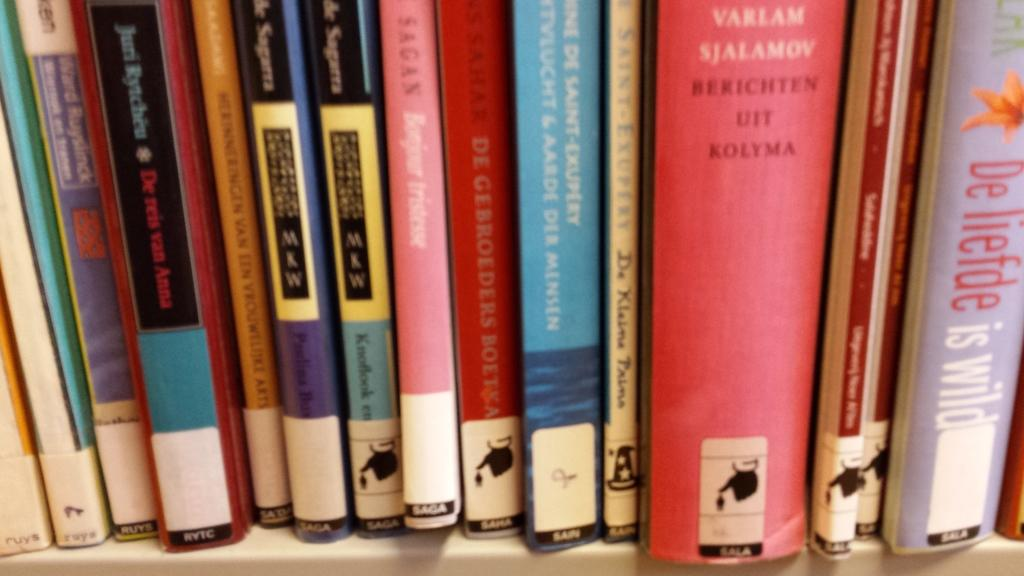<image>
Render a clear and concise summary of the photo. books in a row that say 'varlam ajalamoy berichten uit kolyma' on it 